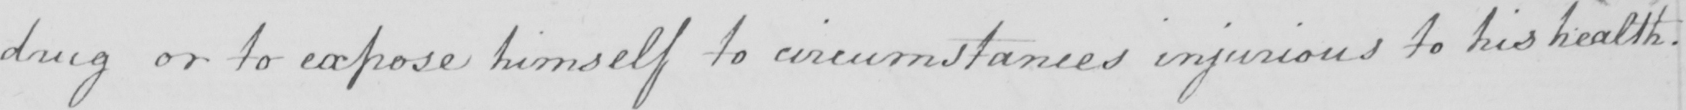Can you tell me what this handwritten text says? drug or to expose himself to circumstances injurious to his health . 